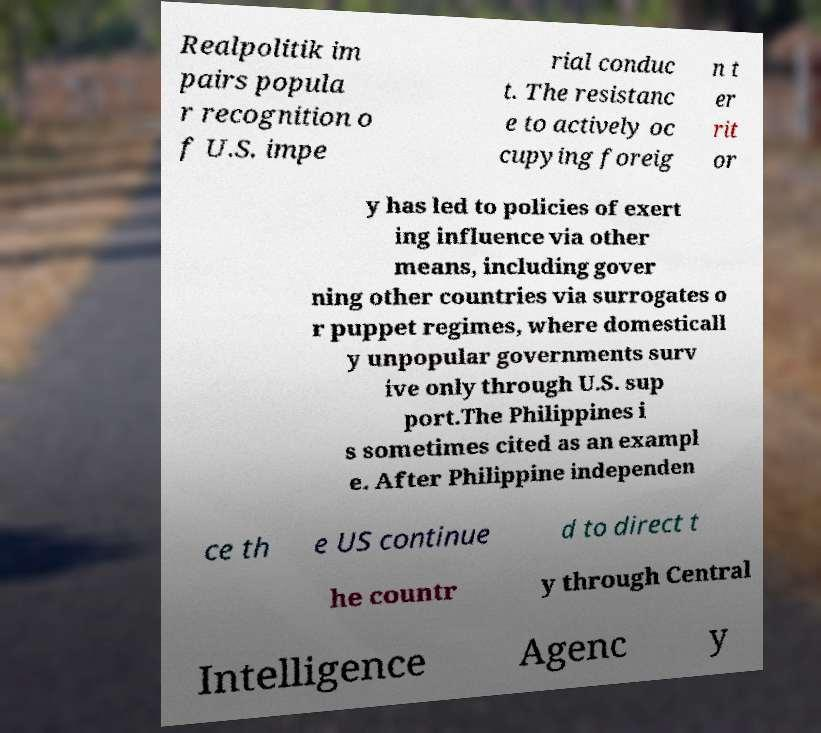There's text embedded in this image that I need extracted. Can you transcribe it verbatim? Realpolitik im pairs popula r recognition o f U.S. impe rial conduc t. The resistanc e to actively oc cupying foreig n t er rit or y has led to policies of exert ing influence via other means, including gover ning other countries via surrogates o r puppet regimes, where domesticall y unpopular governments surv ive only through U.S. sup port.The Philippines i s sometimes cited as an exampl e. After Philippine independen ce th e US continue d to direct t he countr y through Central Intelligence Agenc y 